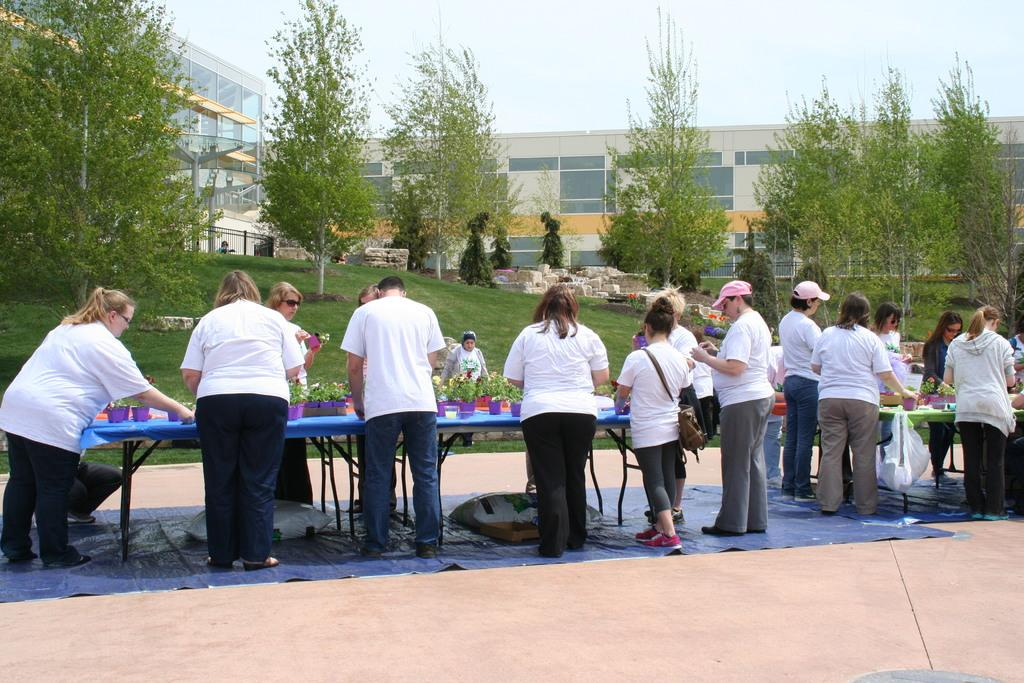How many people are in the image? There is a group of people in the image, but the exact number is not specified. What are the people doing in the image? The people are standing in front of a table. What are the people wearing in the image? The people are wearing white tops. What can be seen in the background of the image? There are trees and at least one building visible in the image. What type of steel is being used to construct the building in the image? There is no information about the type of steel used in the construction of the building in the image. 